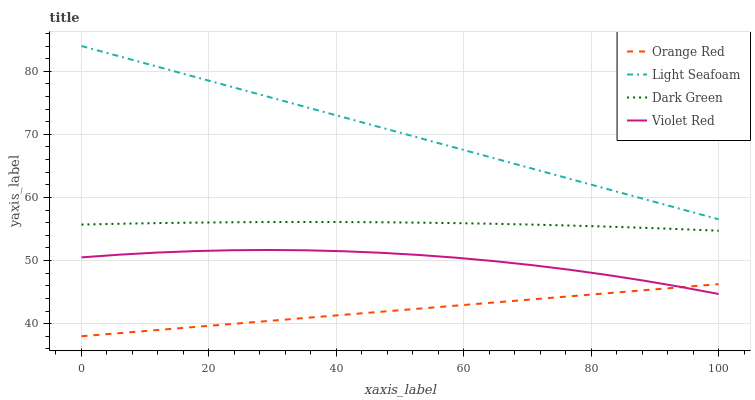Does Orange Red have the minimum area under the curve?
Answer yes or no. Yes. Does Light Seafoam have the maximum area under the curve?
Answer yes or no. Yes. Does Light Seafoam have the minimum area under the curve?
Answer yes or no. No. Does Orange Red have the maximum area under the curve?
Answer yes or no. No. Is Orange Red the smoothest?
Answer yes or no. Yes. Is Violet Red the roughest?
Answer yes or no. Yes. Is Light Seafoam the smoothest?
Answer yes or no. No. Is Light Seafoam the roughest?
Answer yes or no. No. Does Orange Red have the lowest value?
Answer yes or no. Yes. Does Light Seafoam have the lowest value?
Answer yes or no. No. Does Light Seafoam have the highest value?
Answer yes or no. Yes. Does Orange Red have the highest value?
Answer yes or no. No. Is Violet Red less than Dark Green?
Answer yes or no. Yes. Is Dark Green greater than Orange Red?
Answer yes or no. Yes. Does Violet Red intersect Orange Red?
Answer yes or no. Yes. Is Violet Red less than Orange Red?
Answer yes or no. No. Is Violet Red greater than Orange Red?
Answer yes or no. No. Does Violet Red intersect Dark Green?
Answer yes or no. No. 